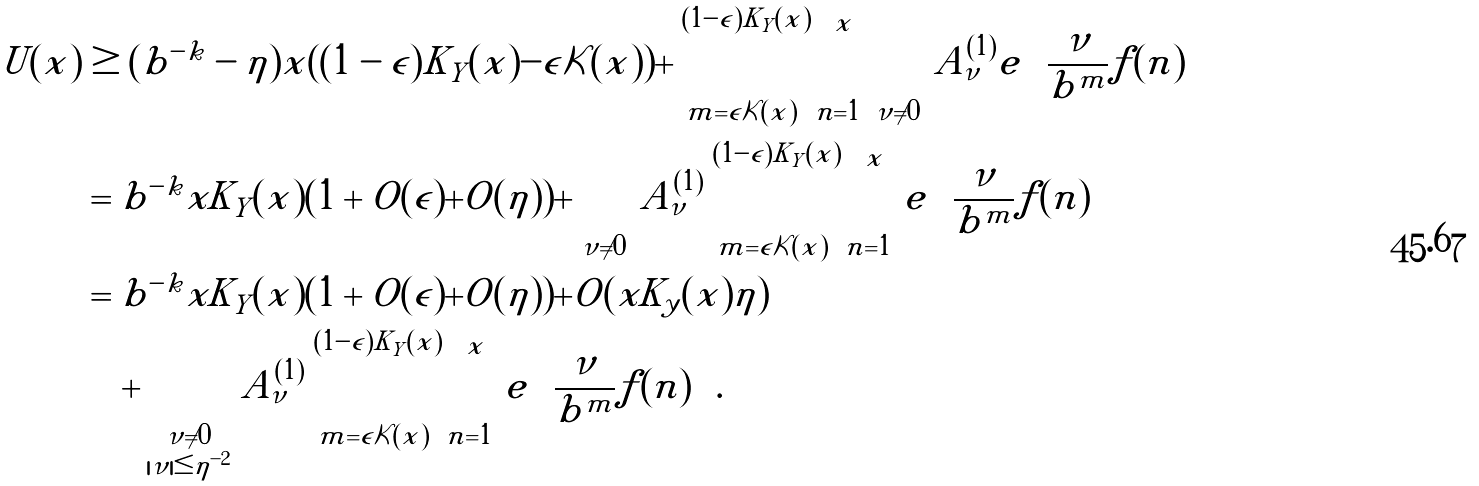Convert formula to latex. <formula><loc_0><loc_0><loc_500><loc_500>U ( x ) & \geq ( b ^ { - k } - \eta ) x ( ( 1 - \epsilon ) K _ { Y } ( x ) - \epsilon \mathcal { K } ( x ) ) + \sum _ { m = \epsilon \mathcal { K } ( x ) } ^ { ( 1 - \epsilon ) K _ { Y } ( x ) } \sum _ { n = 1 } ^ { x } \sum _ { \nu \neq 0 } A _ { \nu } ^ { ( 1 ) } e \left ( \frac { \nu } { b ^ { m } } f ( n ) \right ) \\ & = b ^ { - k } x K _ { Y } ( x ) ( 1 + O ( \epsilon ) + O ( \eta ) ) + \sum _ { \nu \neq 0 } A _ { \nu } ^ { ( 1 ) } \sum _ { m = \epsilon \mathcal { K } ( x ) } ^ { ( 1 - \epsilon ) K _ { Y } ( x ) } \sum _ { n = 1 } ^ { x } e \left ( \frac { \nu } { b ^ { m } } f ( n ) \right ) \\ & = b ^ { - k } x K _ { Y } ( x ) ( 1 + O ( \epsilon ) + O ( \eta ) ) + O ( x K _ { y } ( x ) \eta ) \\ & \quad + \sum _ { \substack { \nu \neq 0 \\ | \nu | \leq \eta ^ { - 2 } } } A _ { \nu } ^ { ( 1 ) } \sum _ { m = \epsilon \mathcal { K } ( x ) } ^ { ( 1 - \epsilon ) K _ { Y } ( x ) } \sum _ { n = 1 } ^ { x } e \left ( \frac { \nu } { b ^ { m } } f ( n ) \right ) .</formula> 